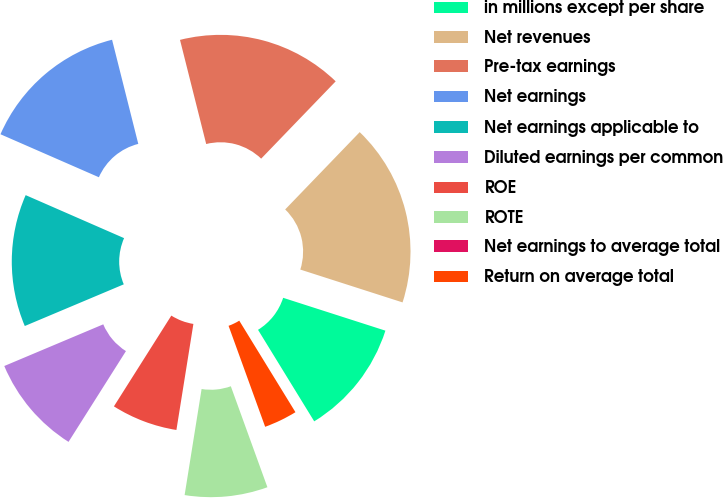<chart> <loc_0><loc_0><loc_500><loc_500><pie_chart><fcel>in millions except per share<fcel>Net revenues<fcel>Pre-tax earnings<fcel>Net earnings<fcel>Net earnings applicable to<fcel>Diluted earnings per common<fcel>ROE<fcel>ROTE<fcel>Net earnings to average total<fcel>Return on average total<nl><fcel>11.29%<fcel>17.74%<fcel>16.13%<fcel>14.52%<fcel>12.9%<fcel>9.68%<fcel>6.45%<fcel>8.06%<fcel>0.0%<fcel>3.23%<nl></chart> 